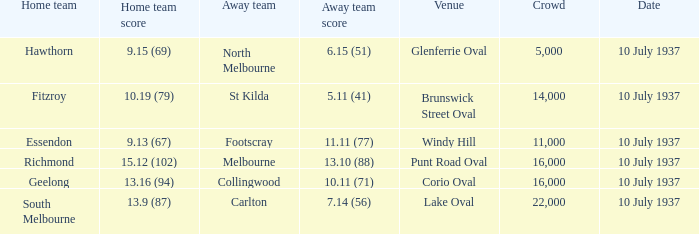What was the smallest audience when the away team scored 1 16000.0. 